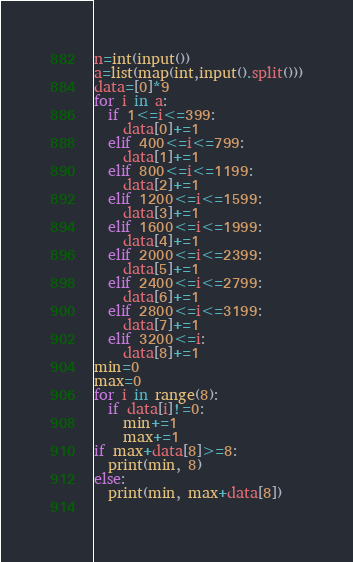Convert code to text. <code><loc_0><loc_0><loc_500><loc_500><_Python_>n=int(input())
a=list(map(int,input().split()))
data=[0]*9
for i in a:
  if 1<=i<=399:
    data[0]+=1
  elif 400<=i<=799:
    data[1]+=1
  elif 800<=i<=1199:
    data[2]+=1
  elif 1200<=i<=1599:
    data[3]+=1
  elif 1600<=i<=1999:
    data[4]+=1
  elif 2000<=i<=2399:
    data[5]+=1
  elif 2400<=i<=2799:
    data[6]+=1
  elif 2800<=i<=3199:
    data[7]+=1
  elif 3200<=i:
    data[8]+=1
min=0
max=0
for i in range(8):
  if data[i]!=0:
    min+=1
    max+=1
if max+data[8]>=8:
  print(min, 8)
else:
  print(min, max+data[8])
    </code> 